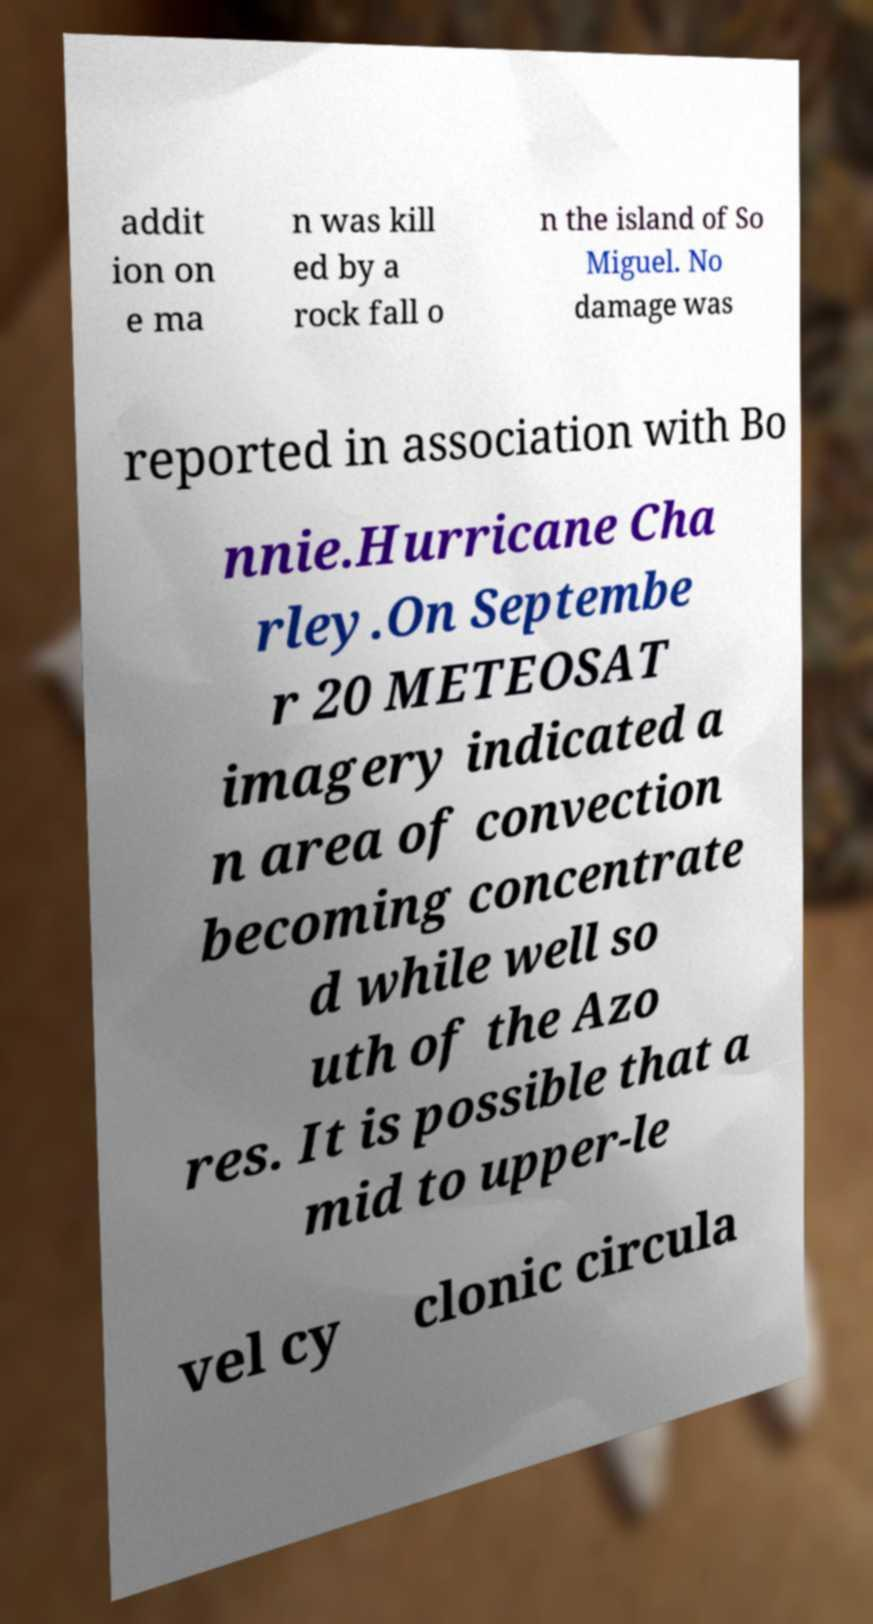There's text embedded in this image that I need extracted. Can you transcribe it verbatim? addit ion on e ma n was kill ed by a rock fall o n the island of So Miguel. No damage was reported in association with Bo nnie.Hurricane Cha rley.On Septembe r 20 METEOSAT imagery indicated a n area of convection becoming concentrate d while well so uth of the Azo res. It is possible that a mid to upper-le vel cy clonic circula 